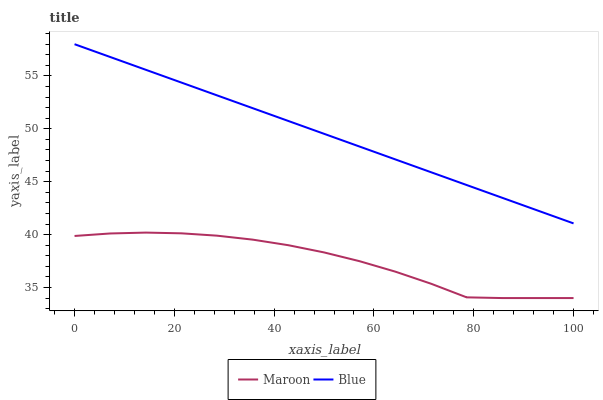Does Maroon have the minimum area under the curve?
Answer yes or no. Yes. Does Blue have the maximum area under the curve?
Answer yes or no. Yes. Does Maroon have the maximum area under the curve?
Answer yes or no. No. Is Blue the smoothest?
Answer yes or no. Yes. Is Maroon the roughest?
Answer yes or no. Yes. Is Maroon the smoothest?
Answer yes or no. No. Does Maroon have the lowest value?
Answer yes or no. Yes. Does Blue have the highest value?
Answer yes or no. Yes. Does Maroon have the highest value?
Answer yes or no. No. Is Maroon less than Blue?
Answer yes or no. Yes. Is Blue greater than Maroon?
Answer yes or no. Yes. Does Maroon intersect Blue?
Answer yes or no. No. 